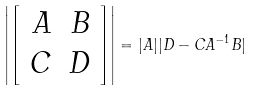<formula> <loc_0><loc_0><loc_500><loc_500>\left | \left [ \begin{array} { r r } A & B \\ C & D \\ \end{array} \right ] \right | = | A | | D - C A ^ { - 1 } B |</formula> 